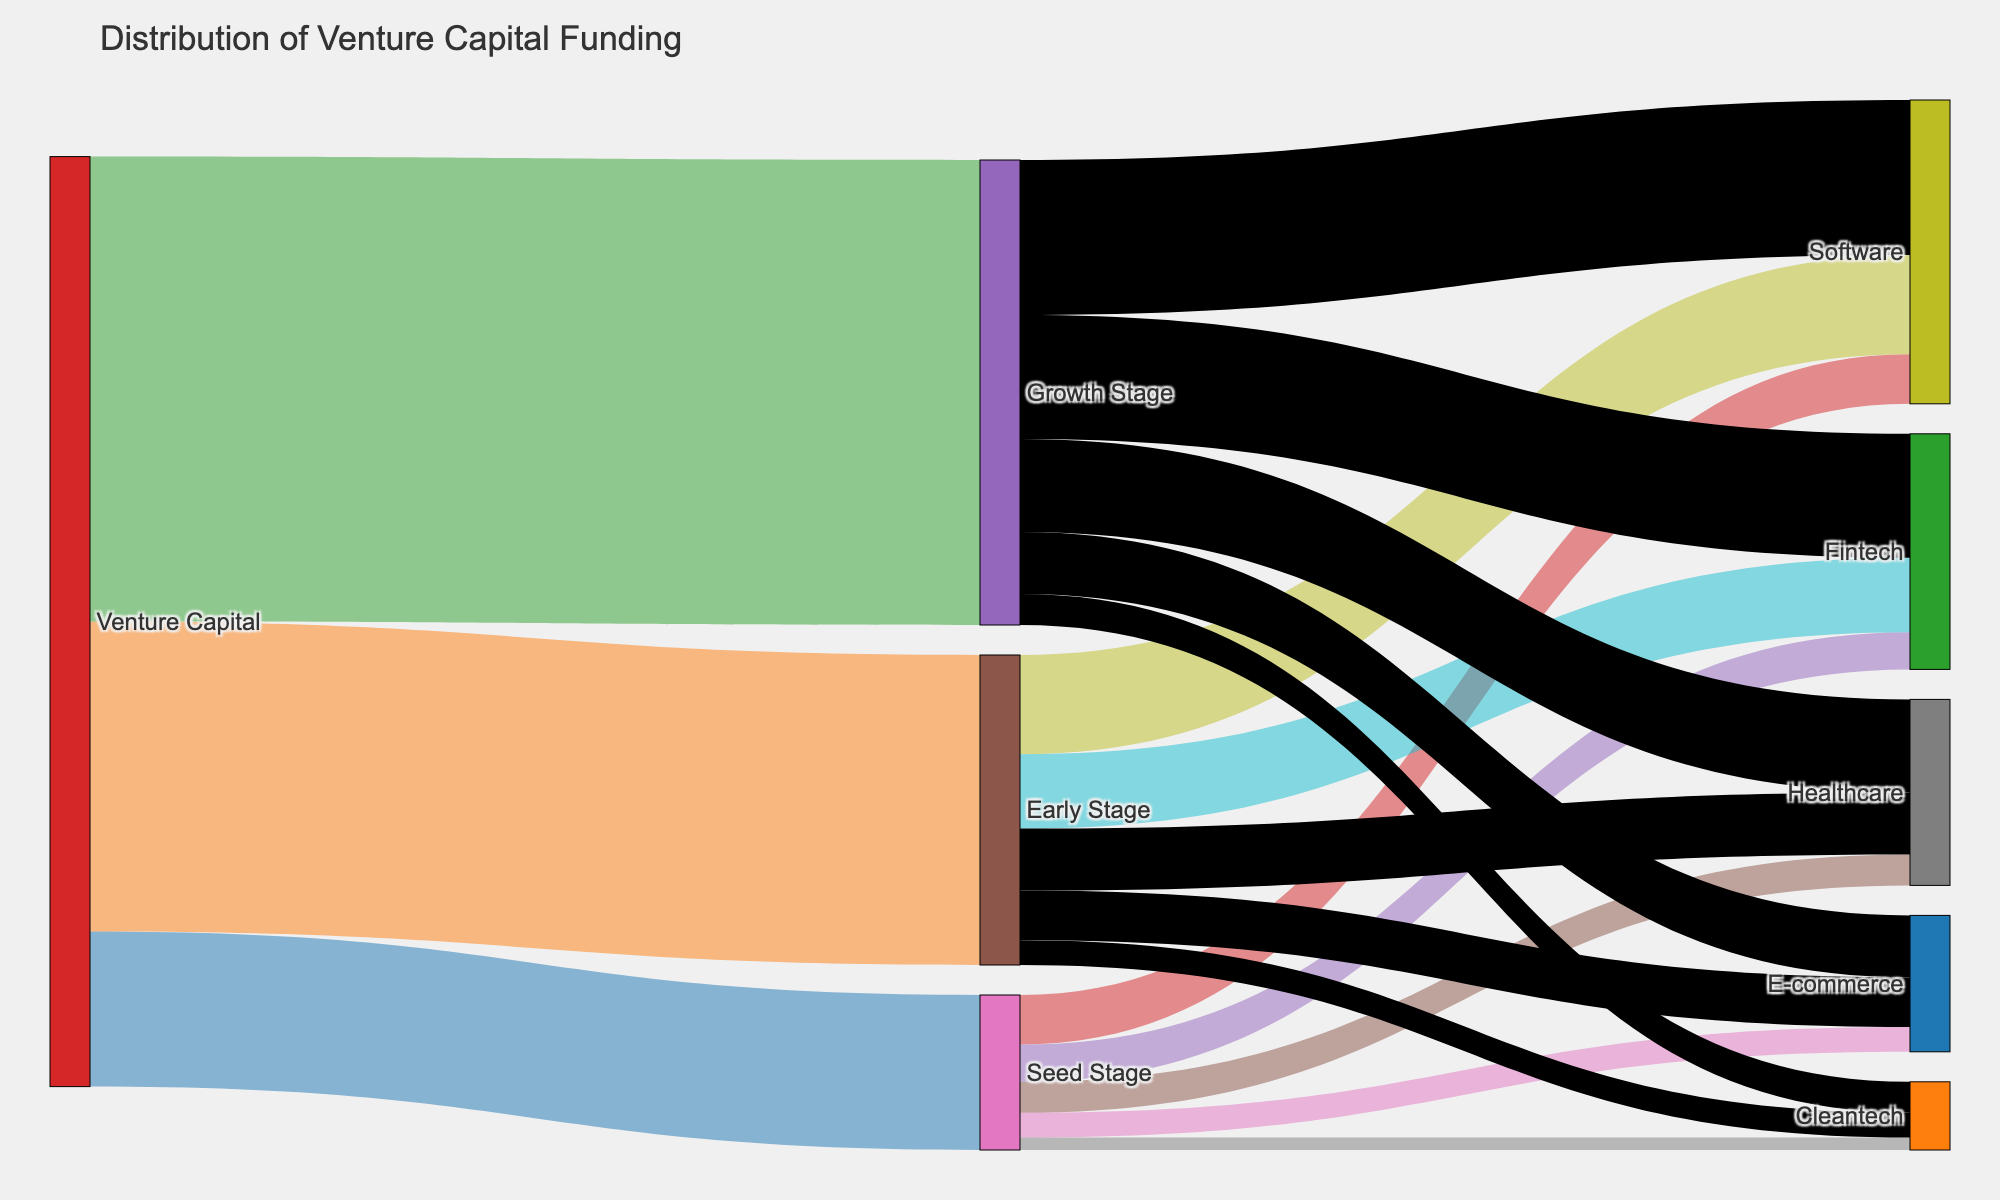What's the title of the figure? The title is normally found at the top center of the figure. In this case, it clearly states "Distribution of Venture Capital Funding".
Answer: Distribution of Venture Capital Funding Which startup stage received the most venture capital funding? By examining the width of the bands from the "Venture Capital" node to the others, the "Growth Stage" node has the thickest band, indicating it received the most funding.
Answer: Growth Stage How much funding in total did the Fintech sector receive? The funding for Fintech is distributed across different stages. Adding up the values, Seed Stage received 600, Early Stage received 1200, and Growth Stage received 2000. Sum: 600 + 1200 + 2000 = 3800.
Answer: 3800 Which sector received the least funding in the Seed Stage? By observing the "Seed Stage" node and tracing to the sectors, the "Cleantech" sector has the smallest band with a value of 200.
Answer: Cleantech Does Software receive more or less funding in the Early Stage compared to the Growth Stage? The band from the "Early Stage" to "Software" shows 1600, while the band from the "Growth Stage" to "Software" shows 2500, indicating the Early Stage received less.
Answer: Less How much funding did the Healthcare sector receive in the Growth Stage? From the "Growth Stage" node to the "Healthcare" sector, the band shows a value of 1500.
Answer: 1500 What's the total funding received by the Healthcare sector across all stages? Sum the values connecting to "Healthcare": Seed Stage 500, Early Stage 1000, Growth Stage 1500. Total: 500 + 1000 + 1500 = 3000.
Answer: 3000 Which stage received more funding, Seed Stage or Early Stage? By comparing the widths of the bands from the "Venture Capital" node, Seed Stage is 2500 and Early Stage is 5000, so Early Stage received more.
Answer: Early Stage How does E-commerce funding in the Growth Stage compare to that in the Seed Stage? E-commerce in Growth Stage has 1000, and in Seed Stage has 400, indicating Growth Stage received more funding.
Answer: Growth Stage received more What's the total venture capital funding distributed across all startup stages? Summing up the values from Venture Capital to each stage: 2500 (Seed) + 5000 (Early) + 7500 (Growth). Total: 2500 + 5000 + 7500 = 15000.
Answer: 15000 